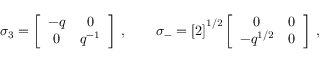Convert formula to latex. <formula><loc_0><loc_0><loc_500><loc_500>\sigma _ { 3 } = \left [ \begin{array} { c c } { - q } & { 0 } \\ { 0 } & { { q ^ { - 1 } } } \end{array} \right ] \, , \quad \sigma _ { - } = \left [ 2 \right ] ^ { 1 / 2 } \left [ \begin{array} { c c } { 0 } & { 0 } \\ { { - q ^ { 1 / 2 } } } & { 0 } \end{array} \right ] \, ,</formula> 